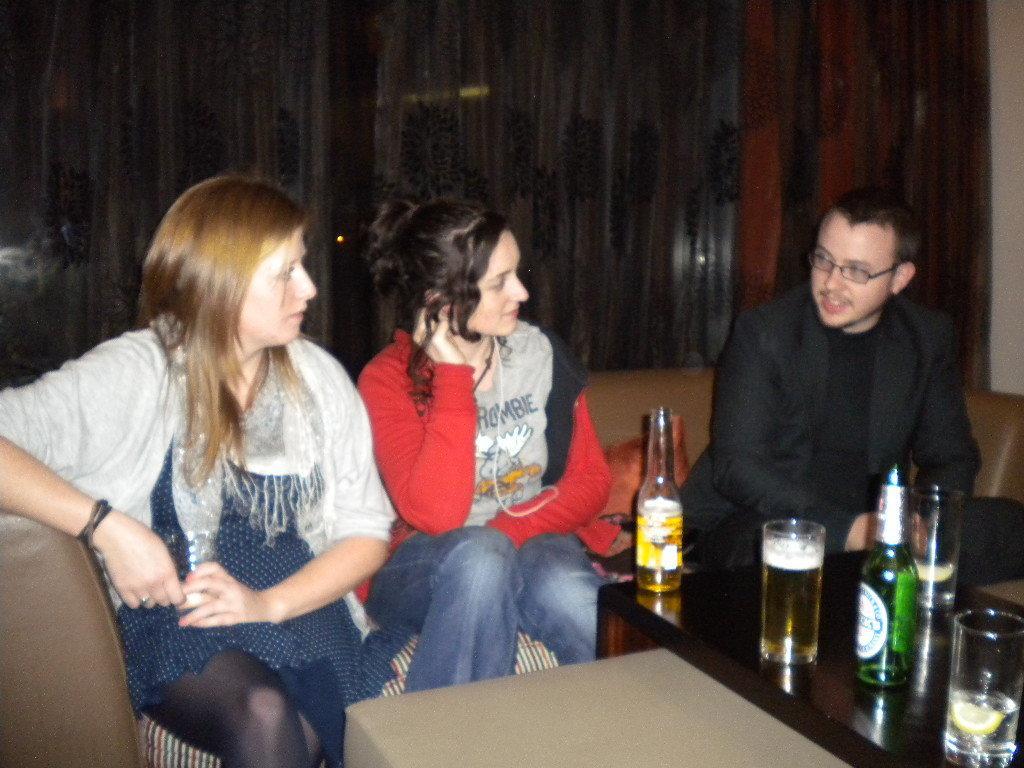Could you give a brief overview of what you see in this image? Two women and a man are sitting on a sofa with two beer bottles and three glasses on a table in front of them. 